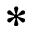<formula> <loc_0><loc_0><loc_500><loc_500>*</formula> 